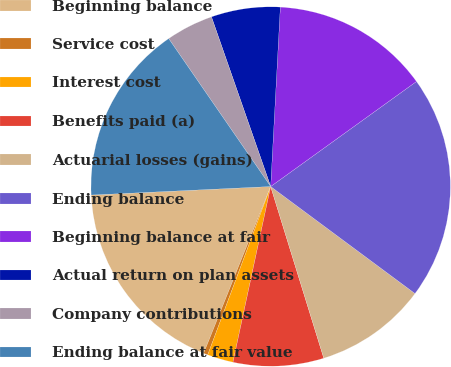Convert chart. <chart><loc_0><loc_0><loc_500><loc_500><pie_chart><fcel>Beginning balance<fcel>Service cost<fcel>Interest cost<fcel>Benefits paid (a)<fcel>Actuarial losses (gains)<fcel>Ending balance<fcel>Beginning balance at fair<fcel>Actual return on plan assets<fcel>Company contributions<fcel>Ending balance at fair value<nl><fcel>18.16%<fcel>0.39%<fcel>2.33%<fcel>8.14%<fcel>10.07%<fcel>20.09%<fcel>14.21%<fcel>6.2%<fcel>4.26%<fcel>16.15%<nl></chart> 